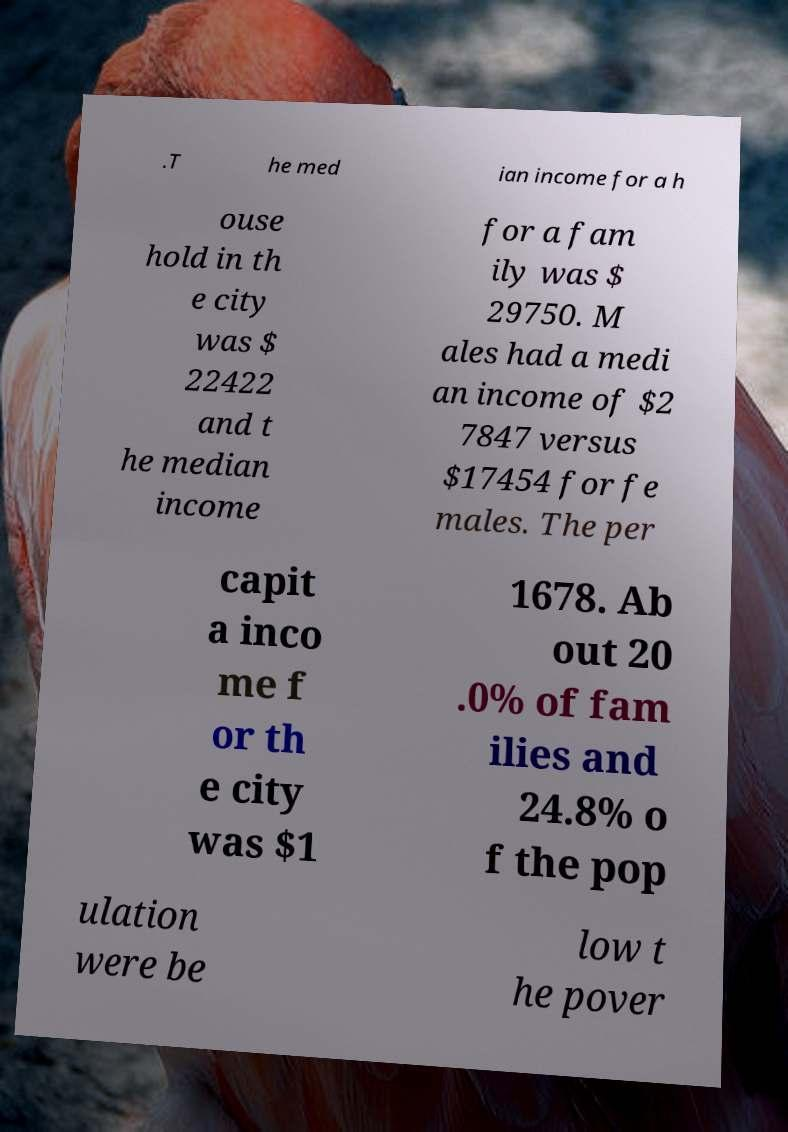There's text embedded in this image that I need extracted. Can you transcribe it verbatim? .T he med ian income for a h ouse hold in th e city was $ 22422 and t he median income for a fam ily was $ 29750. M ales had a medi an income of $2 7847 versus $17454 for fe males. The per capit a inco me f or th e city was $1 1678. Ab out 20 .0% of fam ilies and 24.8% o f the pop ulation were be low t he pover 